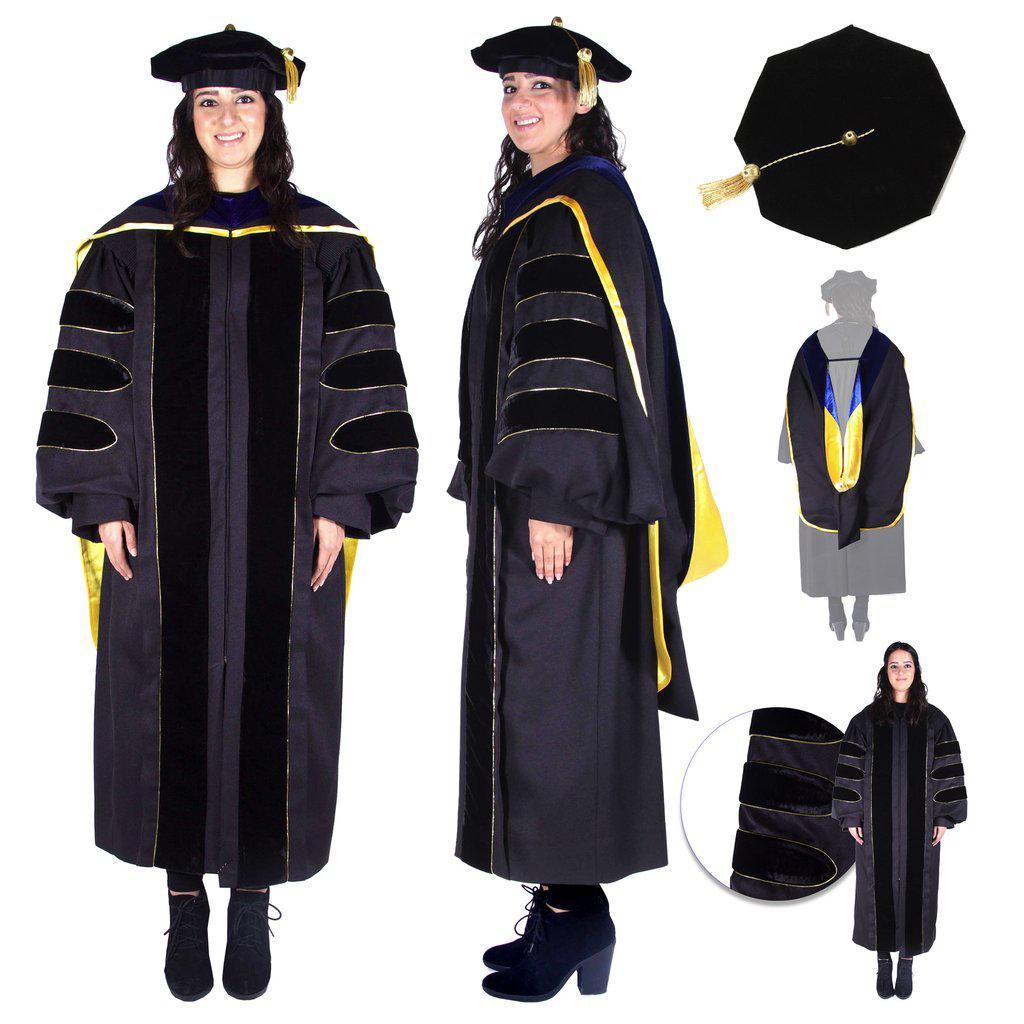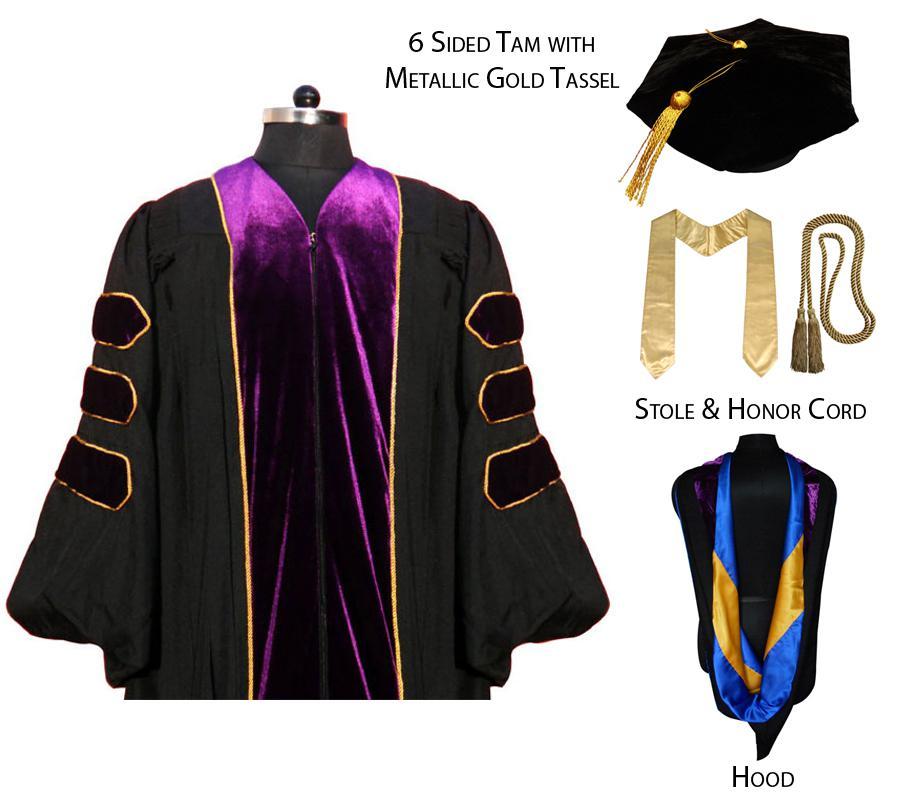The first image is the image on the left, the second image is the image on the right. Considering the images on both sides, is "One image shows the same male graduate in multiple poses, and the other image includes a female graduate." valid? Answer yes or no. No. 